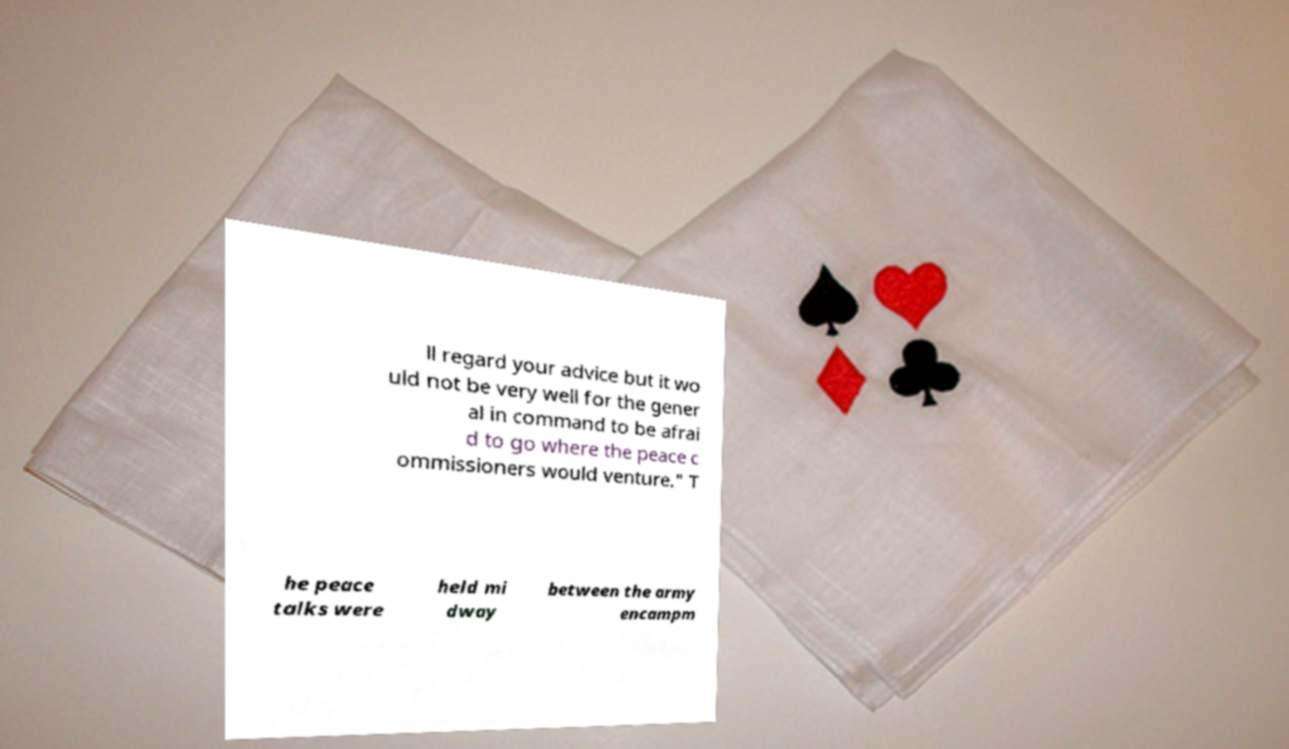For documentation purposes, I need the text within this image transcribed. Could you provide that? ll regard your advice but it wo uld not be very well for the gener al in command to be afrai d to go where the peace c ommissioners would venture." T he peace talks were held mi dway between the army encampm 